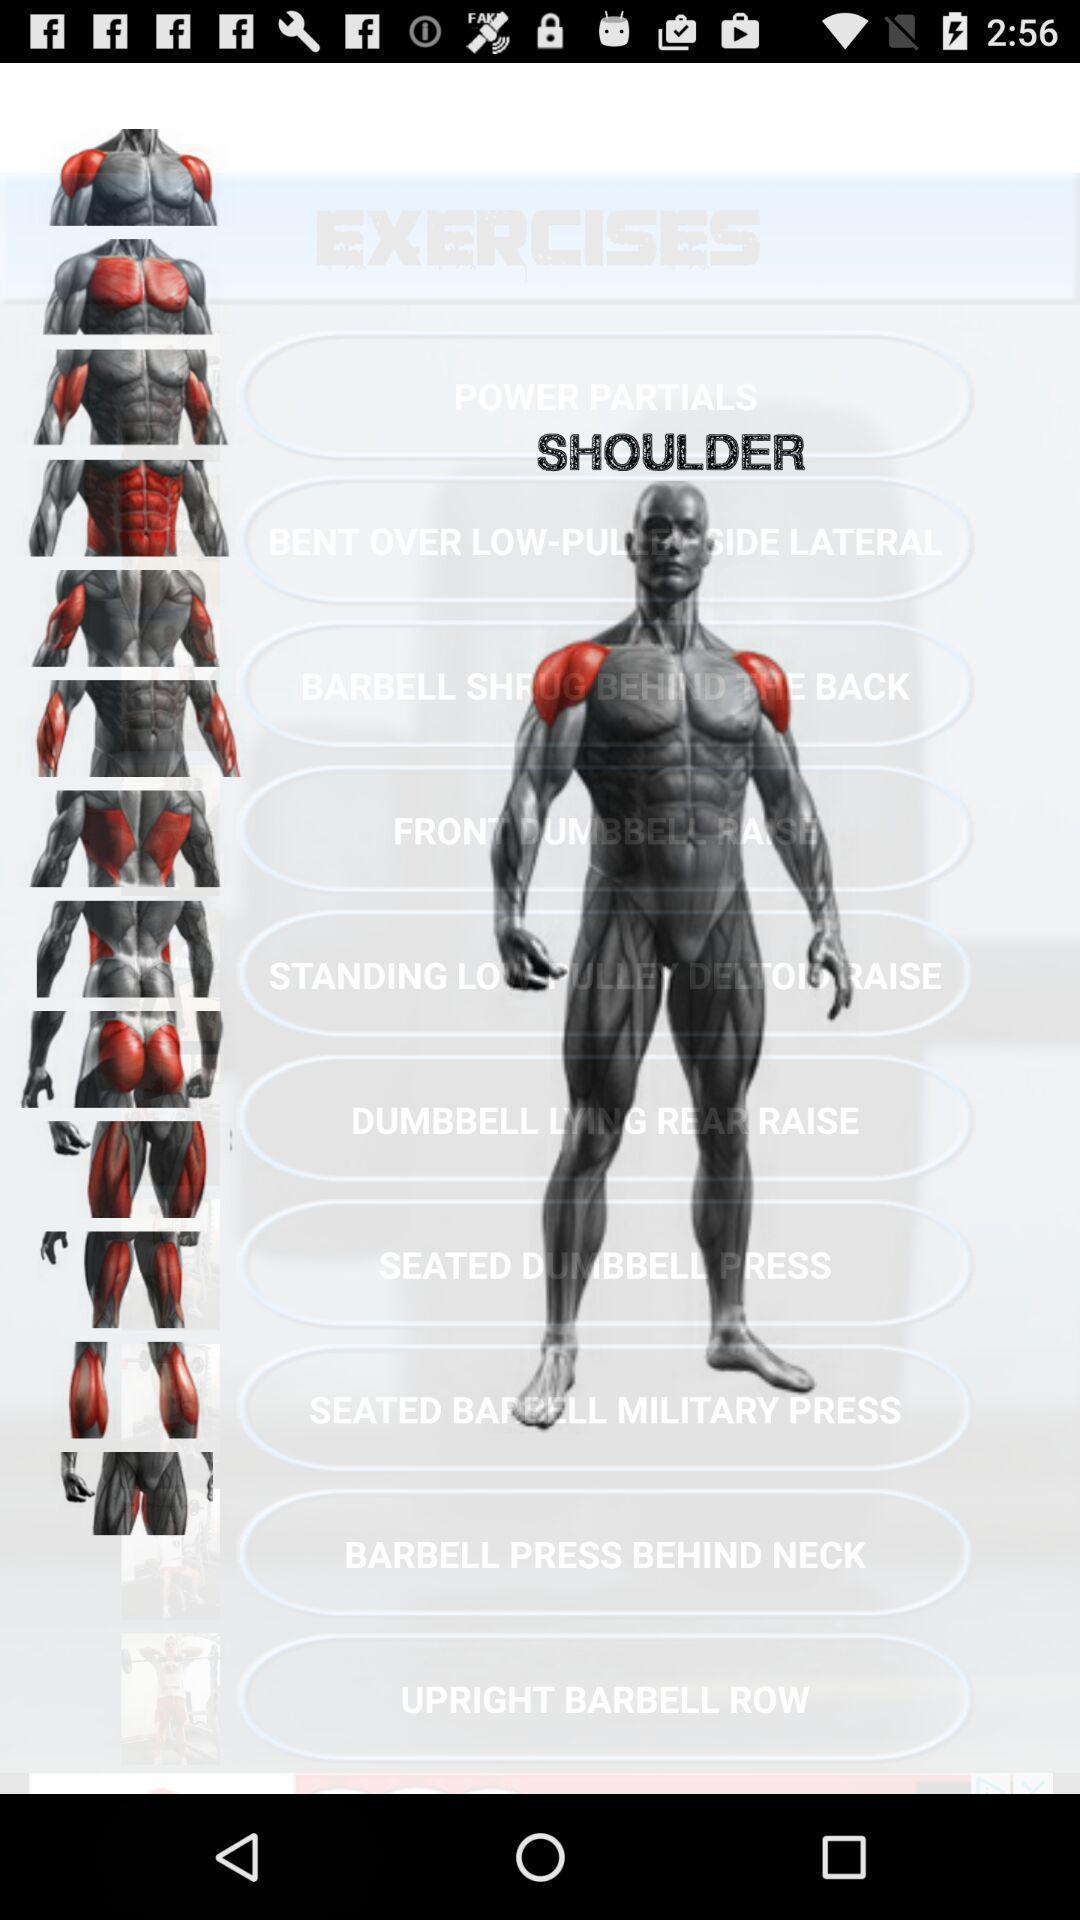Summarize the main components in this picture. Window displaying a fitness app. 